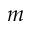<formula> <loc_0><loc_0><loc_500><loc_500>m</formula> 